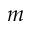<formula> <loc_0><loc_0><loc_500><loc_500>m</formula> 